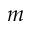<formula> <loc_0><loc_0><loc_500><loc_500>m</formula> 